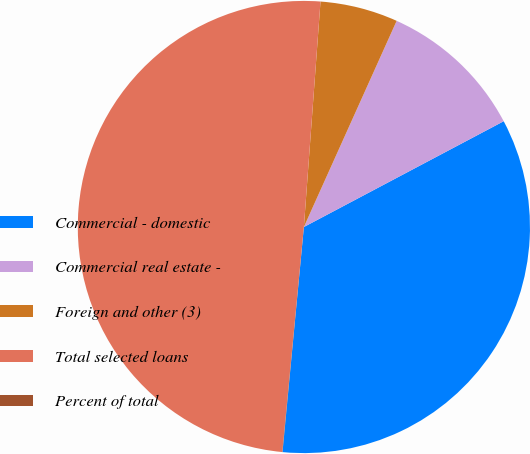Convert chart. <chart><loc_0><loc_0><loc_500><loc_500><pie_chart><fcel>Commercial - domestic<fcel>Commercial real estate -<fcel>Foreign and other (3)<fcel>Total selected loans<fcel>Percent of total<nl><fcel>34.26%<fcel>10.52%<fcel>5.56%<fcel>49.65%<fcel>0.02%<nl></chart> 